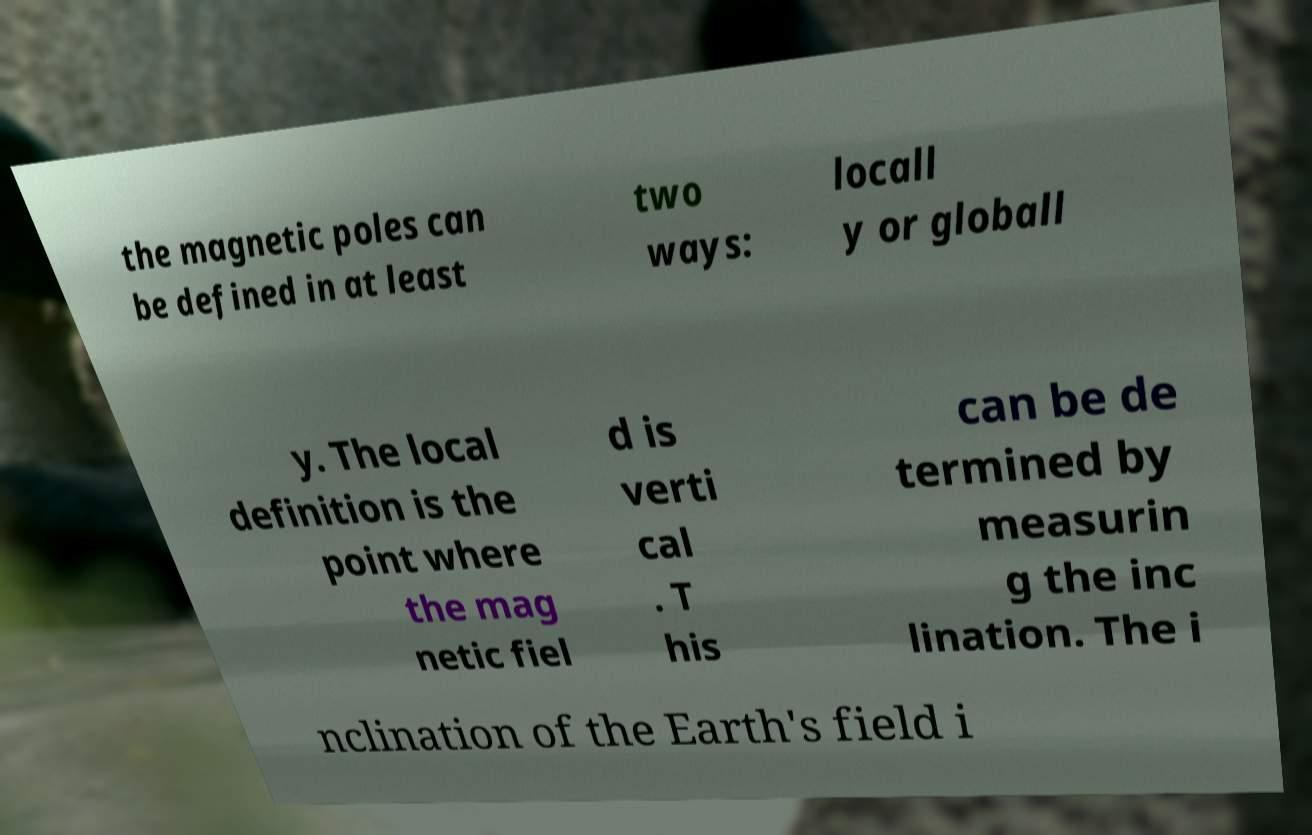What messages or text are displayed in this image? I need them in a readable, typed format. the magnetic poles can be defined in at least two ways: locall y or globall y. The local definition is the point where the mag netic fiel d is verti cal . T his can be de termined by measurin g the inc lination. The i nclination of the Earth's field i 